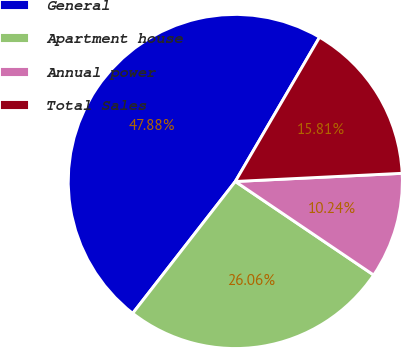Convert chart. <chart><loc_0><loc_0><loc_500><loc_500><pie_chart><fcel>General<fcel>Apartment house<fcel>Annual power<fcel>Total Sales<nl><fcel>47.88%<fcel>26.06%<fcel>10.24%<fcel>15.81%<nl></chart> 